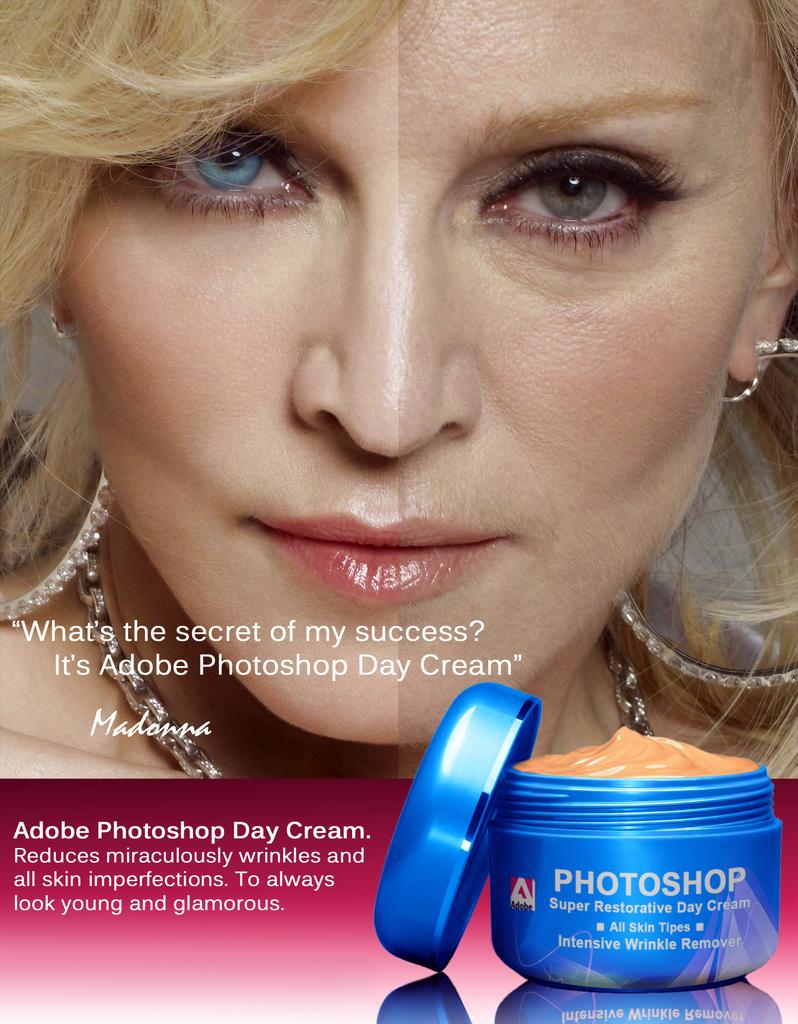What is this cream?
Your answer should be compact. Photoshop. What celebrity is quoted here?
Your answer should be compact. Madonna. 